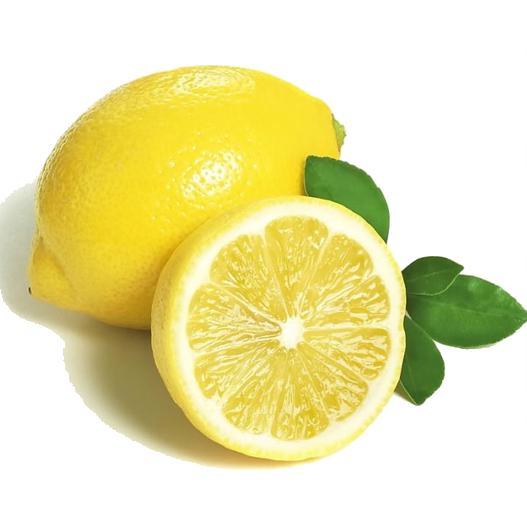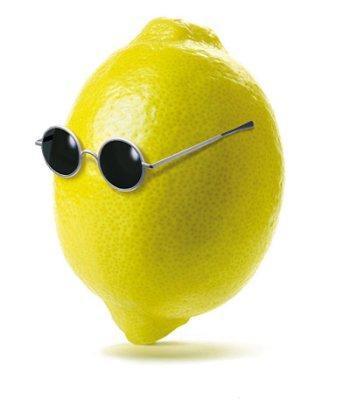The first image is the image on the left, the second image is the image on the right. Evaluate the accuracy of this statement regarding the images: "Both images contain cut lemons.". Is it true? Answer yes or no. No. 